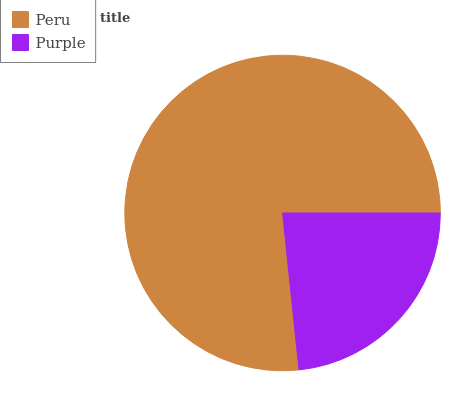Is Purple the minimum?
Answer yes or no. Yes. Is Peru the maximum?
Answer yes or no. Yes. Is Purple the maximum?
Answer yes or no. No. Is Peru greater than Purple?
Answer yes or no. Yes. Is Purple less than Peru?
Answer yes or no. Yes. Is Purple greater than Peru?
Answer yes or no. No. Is Peru less than Purple?
Answer yes or no. No. Is Peru the high median?
Answer yes or no. Yes. Is Purple the low median?
Answer yes or no. Yes. Is Purple the high median?
Answer yes or no. No. Is Peru the low median?
Answer yes or no. No. 